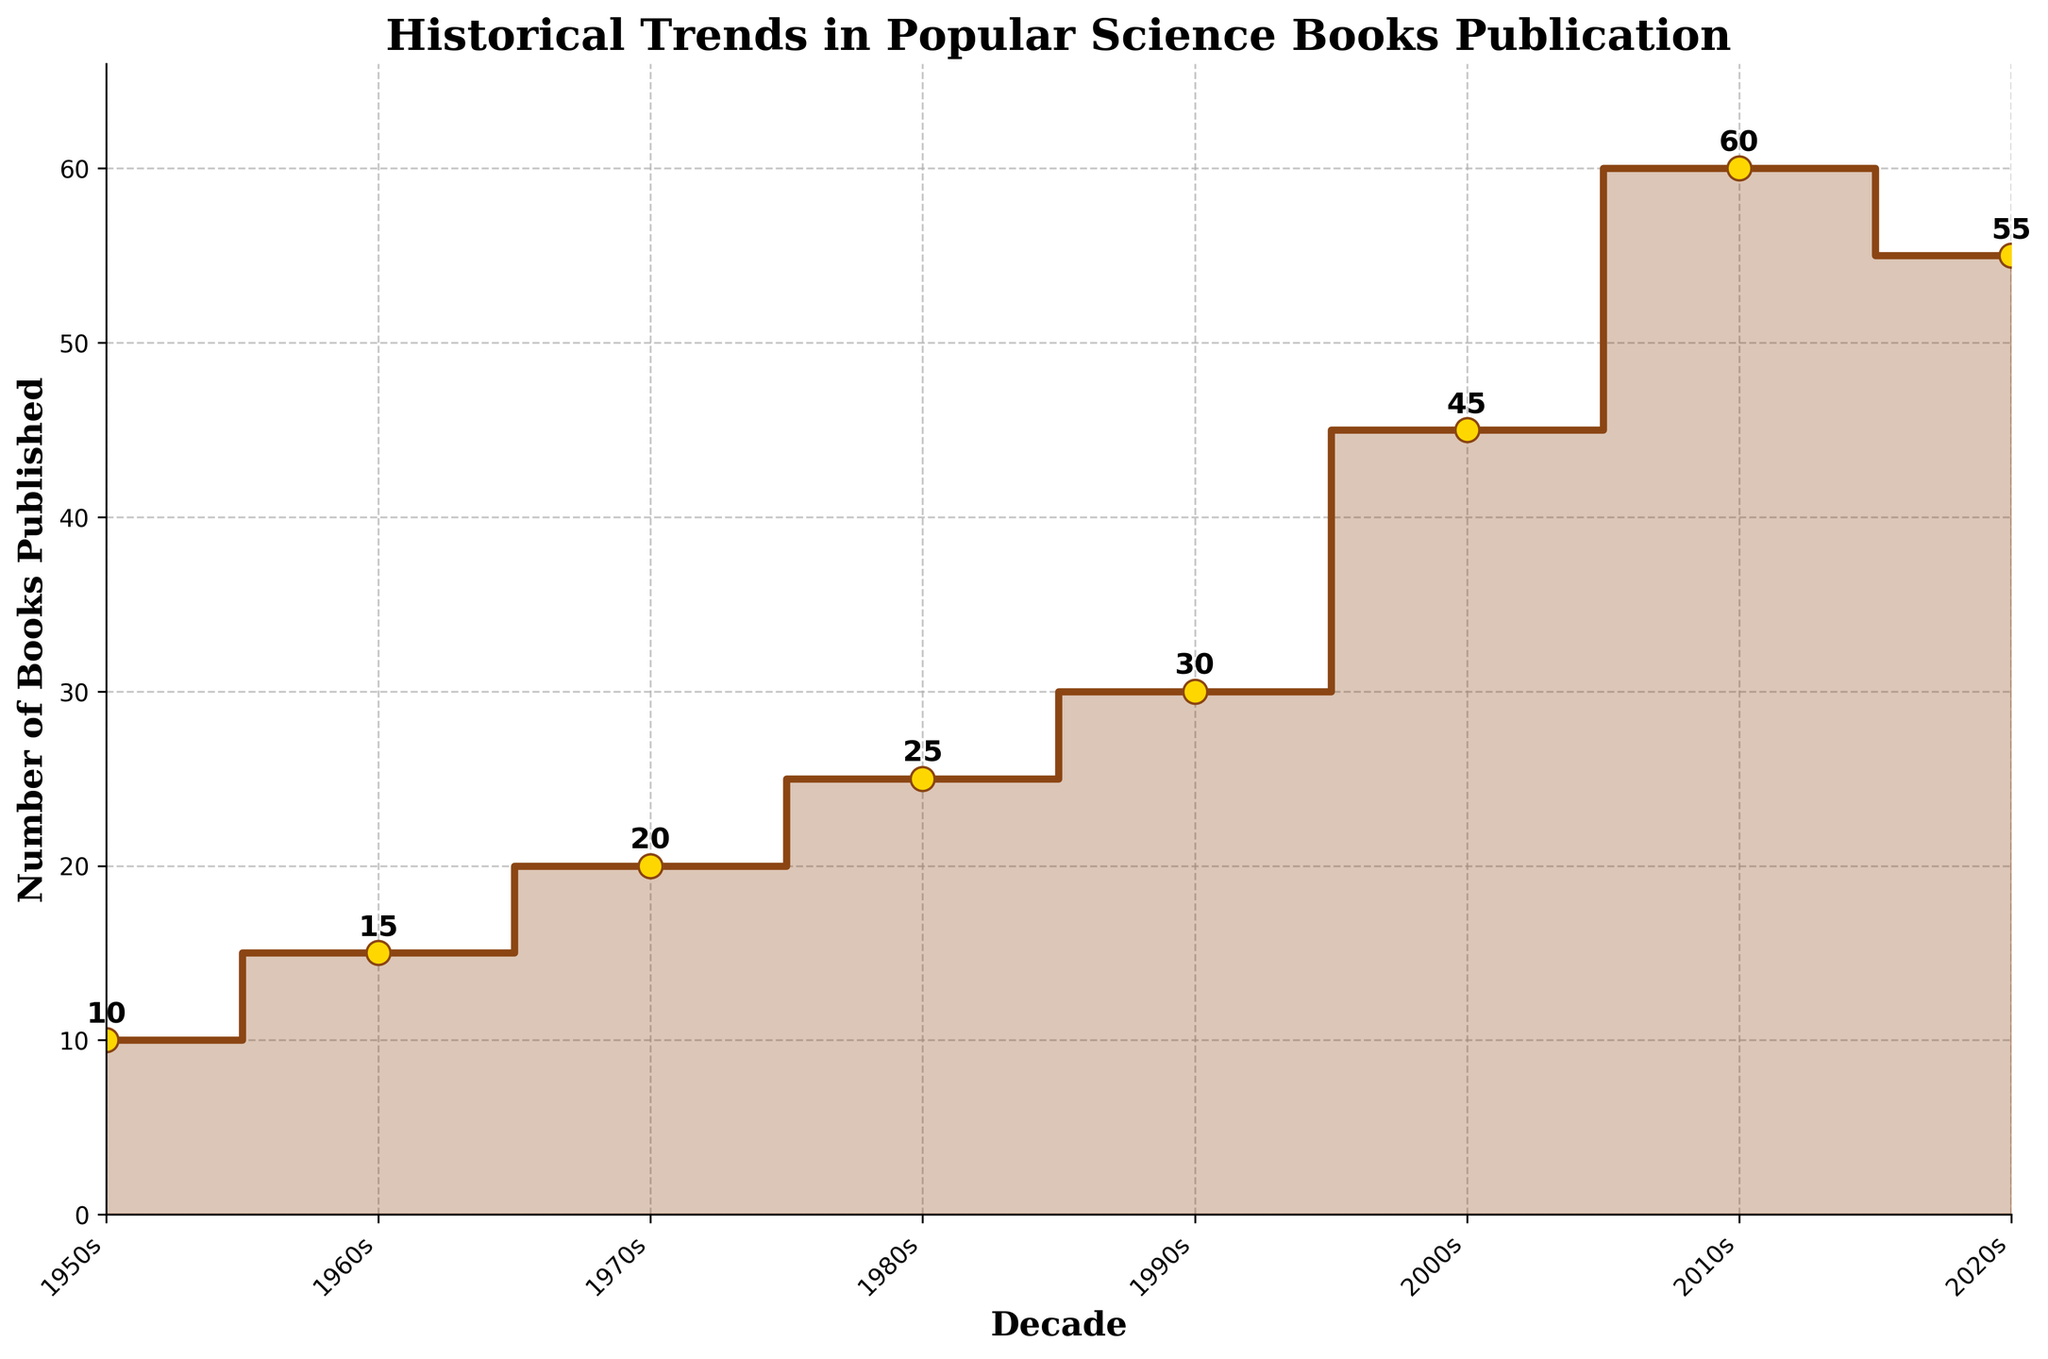What is the title of the figure? The title of the figure is located at the top and serves as a summary of what the data represents.
Answer: Historical Trends in Popular Science Books Publication How many decades are shown in the plot? To determine the number of decades, count the distinct x-axis labels. The decades listed are 1950s, 1960s, 1970s, 1980s, 1990s, 2000s, 2010s, and 2020s.
Answer: 8 In which decade was the highest number of books published? Identify the highest point on the y-axis and match it with the corresponding x-axis label.
Answer: 2010s What is the difference in the number of books published between the 2000s and 2020s? Identify the number of books published in the 2000s and the 2020s, then subtract the smaller value from the larger one: 60 (2020s) - 45 (2000s).
Answer: 15 Did the number of books published increase or decrease from the 2010s to the 2020s? Compare the data points for the 2010s and 2020s to determine the direction of change. In the 2010s, 60 books were published, and in the 2020s, 55 books were published.
Answer: Decrease What is the average number of books published per decade from the 1950s to the 2020s? Sum the number of books for all decades (10+15+20+25+30+45+60+55) and divide by the number of decades (8).
Answer: 32.5 Between which two consecutive decades was the largest increase in the number of books published? Calculate the difference in the number of books published for each consecutive pair of decades and identify the largest increase: (2000s-1990s) = 45-30 = 15.
Answer: 1990s to 2000s Identify the two decades with the smallest difference in the number of books published. Calculate the differences for each pair of consecutive decades, and identify the pair with the smallest difference: (1960s-1950s = 5), (1970s-1960s = 5), (1980s-1970s = 5), (1990s-1980s = 5), (2000s-1990s = 15), (2010s-2000s = 15), (2020s-2010s = 5).
Answer: 1950s to 1960s What trend can you observe in the number of books published from the 1950s to the 2000s? Identify the direction of change over time by observing the data points from the 1950s to the 2000s. The number of books steadily increased each decade.
Answer: Increasing Trend 